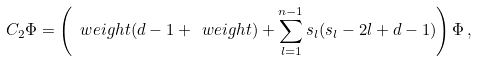Convert formula to latex. <formula><loc_0><loc_0><loc_500><loc_500>C _ { 2 } \Phi = \left ( \ w e i g h t ( d - 1 + \ w e i g h t ) + \sum _ { l = 1 } ^ { n - 1 } s _ { l } ( s _ { l } - 2 l + d - 1 ) \right ) \Phi \, ,</formula> 